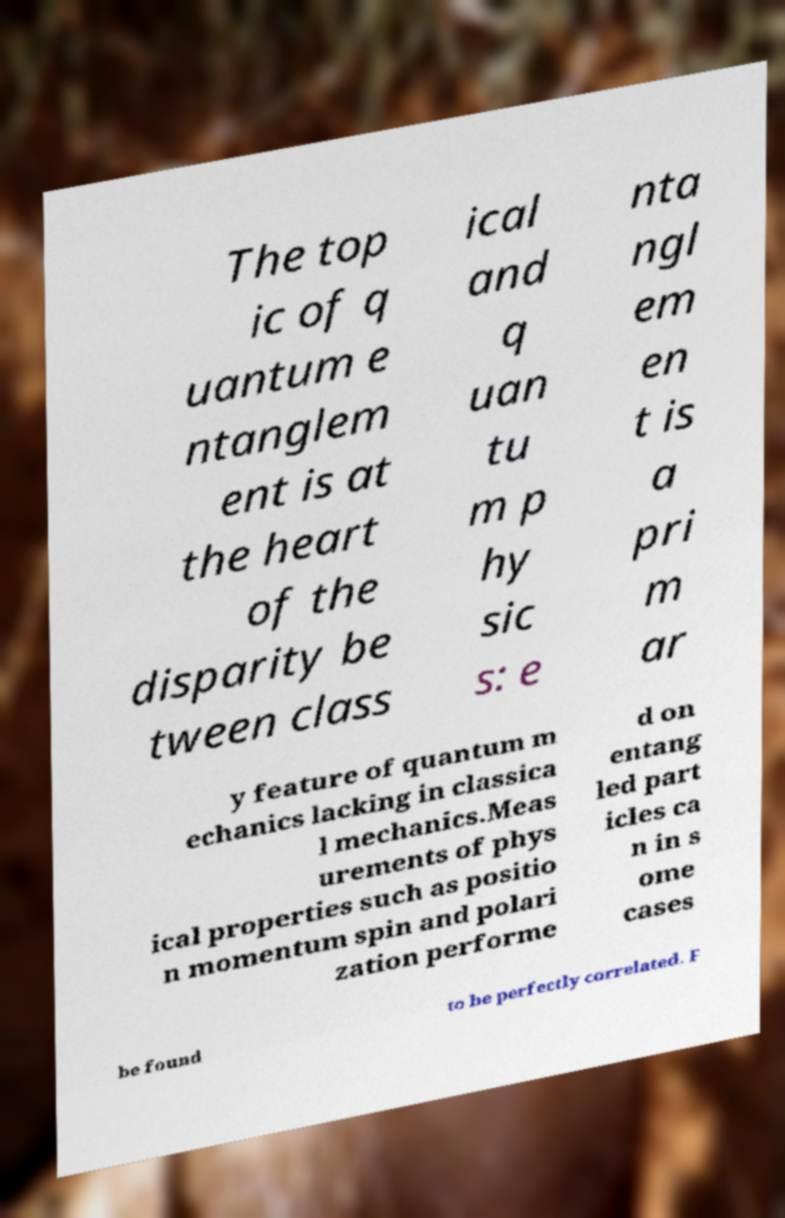There's text embedded in this image that I need extracted. Can you transcribe it verbatim? The top ic of q uantum e ntanglem ent is at the heart of the disparity be tween class ical and q uan tu m p hy sic s: e nta ngl em en t is a pri m ar y feature of quantum m echanics lacking in classica l mechanics.Meas urements of phys ical properties such as positio n momentum spin and polari zation performe d on entang led part icles ca n in s ome cases be found to be perfectly correlated. F 